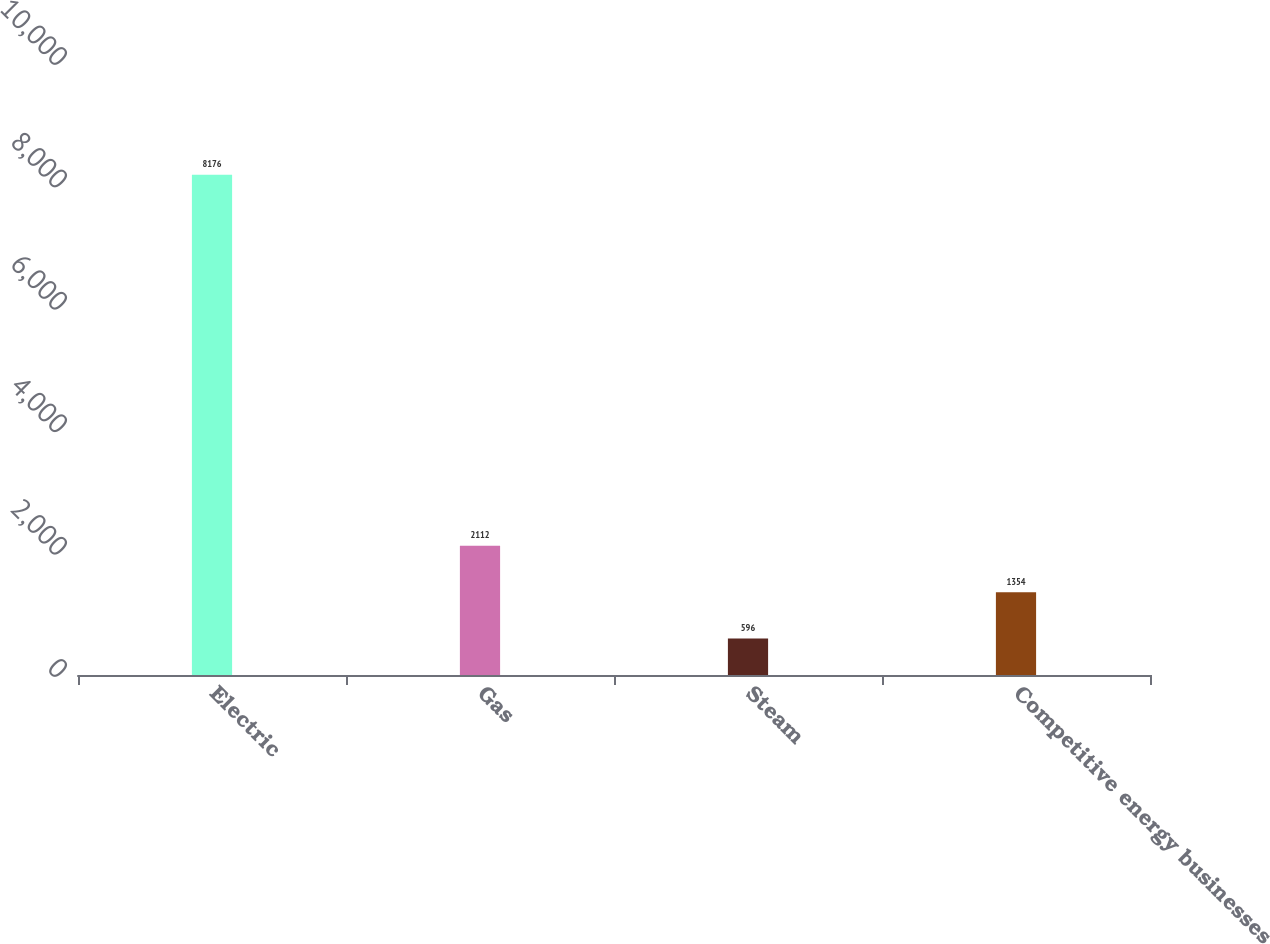Convert chart to OTSL. <chart><loc_0><loc_0><loc_500><loc_500><bar_chart><fcel>Electric<fcel>Gas<fcel>Steam<fcel>Competitive energy businesses<nl><fcel>8176<fcel>2112<fcel>596<fcel>1354<nl></chart> 